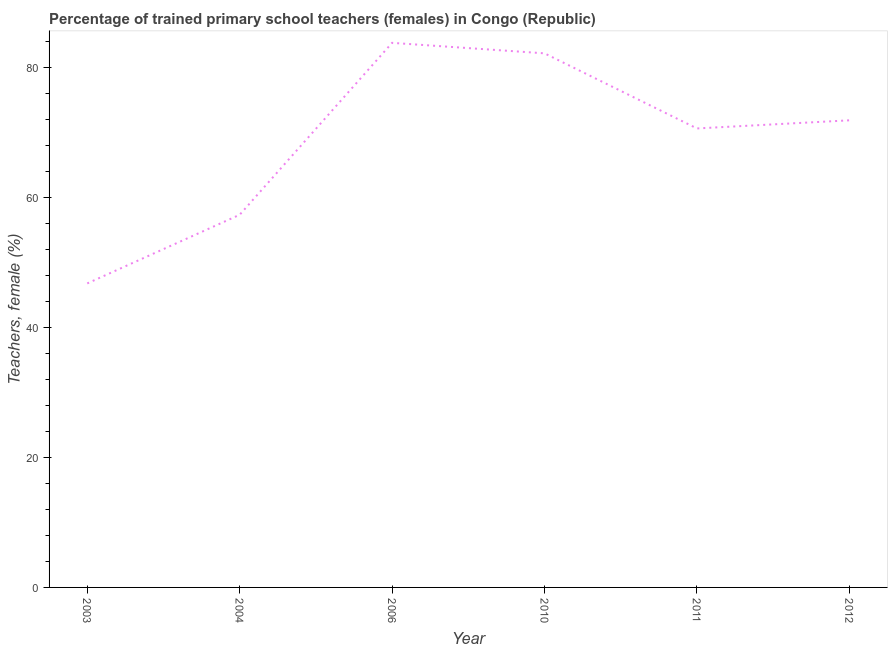What is the percentage of trained female teachers in 2012?
Ensure brevity in your answer.  71.93. Across all years, what is the maximum percentage of trained female teachers?
Your answer should be compact. 83.86. Across all years, what is the minimum percentage of trained female teachers?
Provide a succinct answer. 46.81. In which year was the percentage of trained female teachers minimum?
Provide a succinct answer. 2003. What is the sum of the percentage of trained female teachers?
Offer a terse response. 412.9. What is the difference between the percentage of trained female teachers in 2006 and 2011?
Make the answer very short. 13.18. What is the average percentage of trained female teachers per year?
Keep it short and to the point. 68.82. What is the median percentage of trained female teachers?
Make the answer very short. 71.3. In how many years, is the percentage of trained female teachers greater than 68 %?
Make the answer very short. 4. Do a majority of the years between 2004 and 2011 (inclusive) have percentage of trained female teachers greater than 68 %?
Your response must be concise. Yes. What is the ratio of the percentage of trained female teachers in 2003 to that in 2012?
Provide a short and direct response. 0.65. What is the difference between the highest and the second highest percentage of trained female teachers?
Give a very brief answer. 1.61. What is the difference between the highest and the lowest percentage of trained female teachers?
Make the answer very short. 37.04. Does the percentage of trained female teachers monotonically increase over the years?
Make the answer very short. No. How many years are there in the graph?
Offer a terse response. 6. What is the difference between two consecutive major ticks on the Y-axis?
Provide a short and direct response. 20. Are the values on the major ticks of Y-axis written in scientific E-notation?
Your response must be concise. No. Does the graph contain grids?
Your answer should be very brief. No. What is the title of the graph?
Make the answer very short. Percentage of trained primary school teachers (females) in Congo (Republic). What is the label or title of the Y-axis?
Provide a short and direct response. Teachers, female (%). What is the Teachers, female (%) of 2003?
Your response must be concise. 46.81. What is the Teachers, female (%) in 2004?
Offer a very short reply. 57.38. What is the Teachers, female (%) in 2006?
Make the answer very short. 83.86. What is the Teachers, female (%) in 2010?
Provide a succinct answer. 82.24. What is the Teachers, female (%) of 2011?
Your answer should be very brief. 70.68. What is the Teachers, female (%) of 2012?
Keep it short and to the point. 71.93. What is the difference between the Teachers, female (%) in 2003 and 2004?
Make the answer very short. -10.57. What is the difference between the Teachers, female (%) in 2003 and 2006?
Your response must be concise. -37.04. What is the difference between the Teachers, female (%) in 2003 and 2010?
Offer a terse response. -35.43. What is the difference between the Teachers, female (%) in 2003 and 2011?
Offer a terse response. -23.86. What is the difference between the Teachers, female (%) in 2003 and 2012?
Give a very brief answer. -25.12. What is the difference between the Teachers, female (%) in 2004 and 2006?
Your answer should be very brief. -26.47. What is the difference between the Teachers, female (%) in 2004 and 2010?
Provide a short and direct response. -24.86. What is the difference between the Teachers, female (%) in 2004 and 2011?
Keep it short and to the point. -13.29. What is the difference between the Teachers, female (%) in 2004 and 2012?
Offer a terse response. -14.54. What is the difference between the Teachers, female (%) in 2006 and 2010?
Offer a very short reply. 1.61. What is the difference between the Teachers, female (%) in 2006 and 2011?
Provide a short and direct response. 13.18. What is the difference between the Teachers, female (%) in 2006 and 2012?
Offer a terse response. 11.93. What is the difference between the Teachers, female (%) in 2010 and 2011?
Offer a very short reply. 11.57. What is the difference between the Teachers, female (%) in 2010 and 2012?
Ensure brevity in your answer.  10.31. What is the difference between the Teachers, female (%) in 2011 and 2012?
Make the answer very short. -1.25. What is the ratio of the Teachers, female (%) in 2003 to that in 2004?
Offer a very short reply. 0.82. What is the ratio of the Teachers, female (%) in 2003 to that in 2006?
Your answer should be compact. 0.56. What is the ratio of the Teachers, female (%) in 2003 to that in 2010?
Provide a succinct answer. 0.57. What is the ratio of the Teachers, female (%) in 2003 to that in 2011?
Your answer should be very brief. 0.66. What is the ratio of the Teachers, female (%) in 2003 to that in 2012?
Give a very brief answer. 0.65. What is the ratio of the Teachers, female (%) in 2004 to that in 2006?
Your response must be concise. 0.68. What is the ratio of the Teachers, female (%) in 2004 to that in 2010?
Give a very brief answer. 0.7. What is the ratio of the Teachers, female (%) in 2004 to that in 2011?
Offer a terse response. 0.81. What is the ratio of the Teachers, female (%) in 2004 to that in 2012?
Give a very brief answer. 0.8. What is the ratio of the Teachers, female (%) in 2006 to that in 2010?
Your answer should be compact. 1.02. What is the ratio of the Teachers, female (%) in 2006 to that in 2011?
Offer a terse response. 1.19. What is the ratio of the Teachers, female (%) in 2006 to that in 2012?
Provide a short and direct response. 1.17. What is the ratio of the Teachers, female (%) in 2010 to that in 2011?
Ensure brevity in your answer.  1.16. What is the ratio of the Teachers, female (%) in 2010 to that in 2012?
Offer a terse response. 1.14. What is the ratio of the Teachers, female (%) in 2011 to that in 2012?
Your response must be concise. 0.98. 